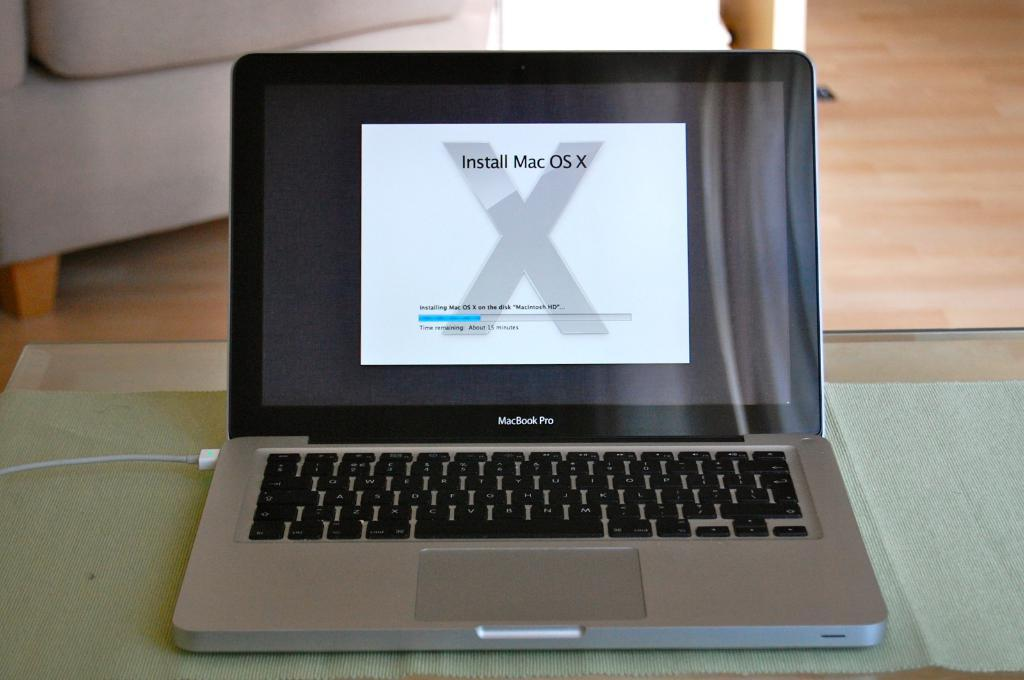<image>
Write a terse but informative summary of the picture. An open Macbook shows a screen to install Mac OS X. 